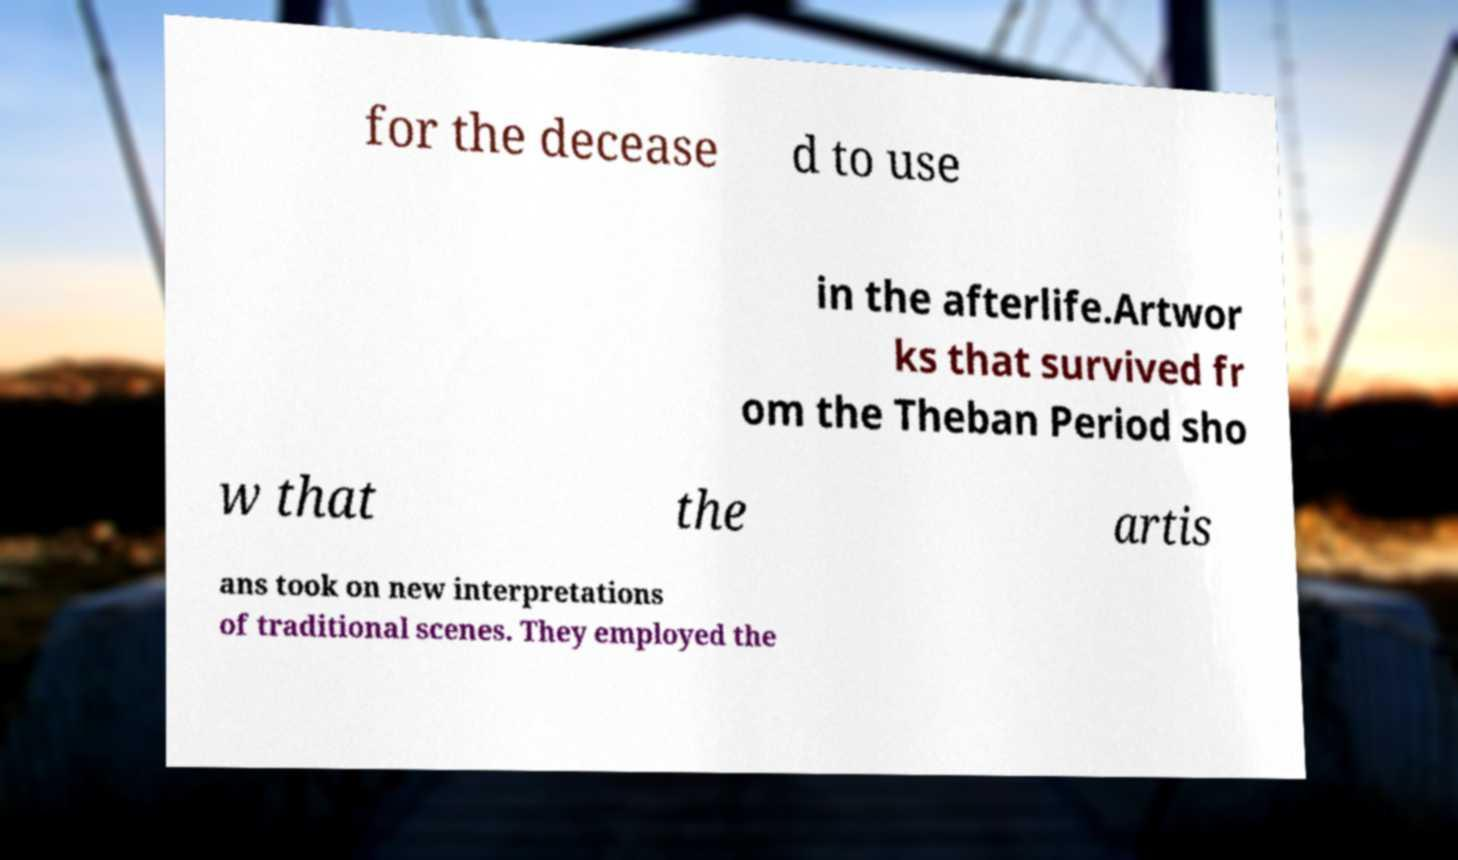I need the written content from this picture converted into text. Can you do that? for the decease d to use in the afterlife.Artwor ks that survived fr om the Theban Period sho w that the artis ans took on new interpretations of traditional scenes. They employed the 